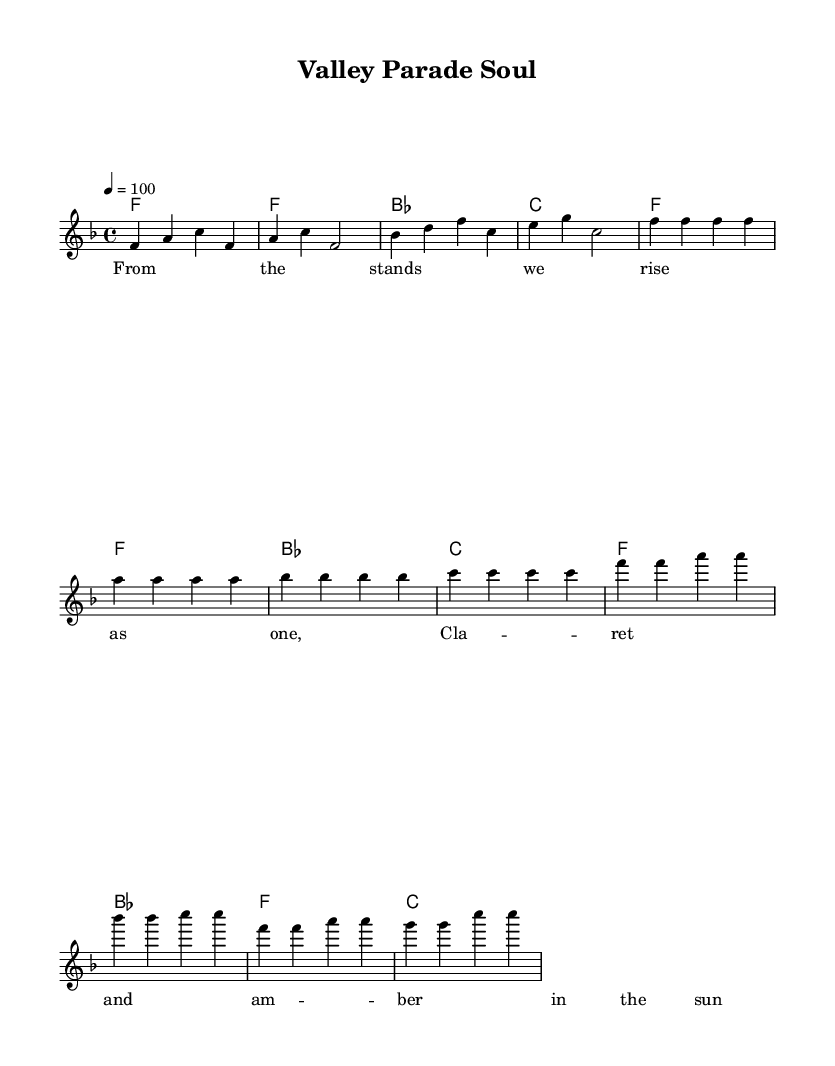What is the key signature of this music? The key signature is F major, which has one flat (B flat).
Answer: F major What is the time signature of this music? The time signature is 4/4, meaning there are four beats in each measure and the quarter note gets one beat.
Answer: 4/4 What is the tempo marking of this music? The tempo marking is 100 beats per minute, indicating the speed at which the piece should be played.
Answer: 100 How many measures are in the verse section? There are four measures in the verse section as indicated in the sheet music.
Answer: 4 What are the starting notes of the melody in the chorus? The starting notes of the melody in the chorus are F and A as shown in the first measure of the chorus.
Answer: F and A What is the lyrical theme of the song based on the lyrics provided? The lyrical theme emphasizes unity and support among football fans, focusing on the shared experience at Valley Parade.
Answer: Unity and support How many different chords are used in the chorus? There are three different chords used in the chorus: F, B flat, and C.
Answer: 3 